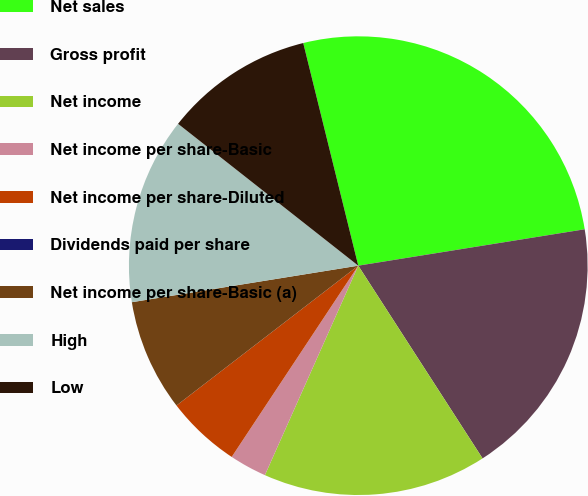Convert chart to OTSL. <chart><loc_0><loc_0><loc_500><loc_500><pie_chart><fcel>Net sales<fcel>Gross profit<fcel>Net income<fcel>Net income per share-Basic<fcel>Net income per share-Diluted<fcel>Dividends paid per share<fcel>Net income per share-Basic (a)<fcel>High<fcel>Low<nl><fcel>26.32%<fcel>18.42%<fcel>15.79%<fcel>2.63%<fcel>5.26%<fcel>0.0%<fcel>7.89%<fcel>13.16%<fcel>10.53%<nl></chart> 